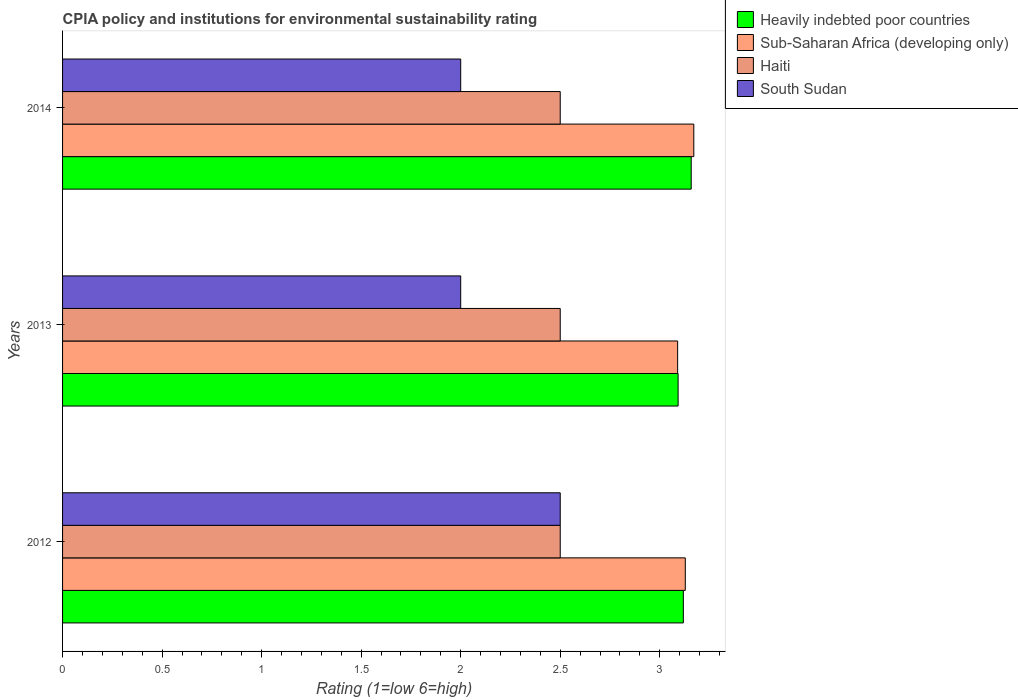How many different coloured bars are there?
Your answer should be very brief. 4. How many groups of bars are there?
Give a very brief answer. 3. Are the number of bars on each tick of the Y-axis equal?
Offer a terse response. Yes. How many bars are there on the 3rd tick from the top?
Keep it short and to the point. 4. How many bars are there on the 3rd tick from the bottom?
Provide a succinct answer. 4. In how many cases, is the number of bars for a given year not equal to the number of legend labels?
Ensure brevity in your answer.  0. Across all years, what is the maximum CPIA rating in Sub-Saharan Africa (developing only)?
Provide a succinct answer. 3.17. Across all years, what is the minimum CPIA rating in Sub-Saharan Africa (developing only)?
Ensure brevity in your answer.  3.09. What is the total CPIA rating in Heavily indebted poor countries in the graph?
Your response must be concise. 9.37. What is the difference between the CPIA rating in Sub-Saharan Africa (developing only) in 2013 and that in 2014?
Your response must be concise. -0.08. What is the difference between the CPIA rating in Heavily indebted poor countries in 2014 and the CPIA rating in Haiti in 2013?
Offer a very short reply. 0.66. What is the average CPIA rating in Heavily indebted poor countries per year?
Ensure brevity in your answer.  3.12. In how many years, is the CPIA rating in Heavily indebted poor countries greater than 0.5 ?
Provide a short and direct response. 3. What is the ratio of the CPIA rating in Heavily indebted poor countries in 2012 to that in 2013?
Offer a terse response. 1.01. Is the CPIA rating in Heavily indebted poor countries in 2012 less than that in 2014?
Provide a short and direct response. Yes. What is the difference between the highest and the second highest CPIA rating in Heavily indebted poor countries?
Your answer should be compact. 0.04. What is the difference between the highest and the lowest CPIA rating in Sub-Saharan Africa (developing only)?
Give a very brief answer. 0.08. Is the sum of the CPIA rating in Heavily indebted poor countries in 2013 and 2014 greater than the maximum CPIA rating in Haiti across all years?
Your answer should be compact. Yes. What does the 2nd bar from the top in 2014 represents?
Offer a terse response. Haiti. What does the 1st bar from the bottom in 2013 represents?
Your answer should be very brief. Heavily indebted poor countries. Is it the case that in every year, the sum of the CPIA rating in Haiti and CPIA rating in Heavily indebted poor countries is greater than the CPIA rating in Sub-Saharan Africa (developing only)?
Your answer should be compact. Yes. Are all the bars in the graph horizontal?
Provide a short and direct response. Yes. How many years are there in the graph?
Your response must be concise. 3. Are the values on the major ticks of X-axis written in scientific E-notation?
Provide a short and direct response. No. Does the graph contain any zero values?
Offer a terse response. No. How many legend labels are there?
Give a very brief answer. 4. How are the legend labels stacked?
Offer a very short reply. Vertical. What is the title of the graph?
Offer a terse response. CPIA policy and institutions for environmental sustainability rating. What is the Rating (1=low 6=high) of Heavily indebted poor countries in 2012?
Your answer should be compact. 3.12. What is the Rating (1=low 6=high) in Sub-Saharan Africa (developing only) in 2012?
Your response must be concise. 3.13. What is the Rating (1=low 6=high) in South Sudan in 2012?
Offer a very short reply. 2.5. What is the Rating (1=low 6=high) of Heavily indebted poor countries in 2013?
Give a very brief answer. 3.09. What is the Rating (1=low 6=high) of Sub-Saharan Africa (developing only) in 2013?
Ensure brevity in your answer.  3.09. What is the Rating (1=low 6=high) of South Sudan in 2013?
Your answer should be very brief. 2. What is the Rating (1=low 6=high) of Heavily indebted poor countries in 2014?
Your response must be concise. 3.16. What is the Rating (1=low 6=high) of Sub-Saharan Africa (developing only) in 2014?
Provide a short and direct response. 3.17. What is the Rating (1=low 6=high) of Haiti in 2014?
Provide a short and direct response. 2.5. What is the Rating (1=low 6=high) in South Sudan in 2014?
Your answer should be compact. 2. Across all years, what is the maximum Rating (1=low 6=high) in Heavily indebted poor countries?
Offer a very short reply. 3.16. Across all years, what is the maximum Rating (1=low 6=high) of Sub-Saharan Africa (developing only)?
Your answer should be compact. 3.17. Across all years, what is the maximum Rating (1=low 6=high) of Haiti?
Keep it short and to the point. 2.5. Across all years, what is the minimum Rating (1=low 6=high) in Heavily indebted poor countries?
Your answer should be very brief. 3.09. Across all years, what is the minimum Rating (1=low 6=high) in Sub-Saharan Africa (developing only)?
Offer a terse response. 3.09. Across all years, what is the minimum Rating (1=low 6=high) in Haiti?
Provide a short and direct response. 2.5. What is the total Rating (1=low 6=high) of Heavily indebted poor countries in the graph?
Offer a very short reply. 9.37. What is the total Rating (1=low 6=high) of Sub-Saharan Africa (developing only) in the graph?
Keep it short and to the point. 9.39. What is the total Rating (1=low 6=high) in Haiti in the graph?
Provide a short and direct response. 7.5. What is the total Rating (1=low 6=high) of South Sudan in the graph?
Ensure brevity in your answer.  6.5. What is the difference between the Rating (1=low 6=high) of Heavily indebted poor countries in 2012 and that in 2013?
Keep it short and to the point. 0.03. What is the difference between the Rating (1=low 6=high) of Sub-Saharan Africa (developing only) in 2012 and that in 2013?
Make the answer very short. 0.04. What is the difference between the Rating (1=low 6=high) of Haiti in 2012 and that in 2013?
Offer a terse response. 0. What is the difference between the Rating (1=low 6=high) in Heavily indebted poor countries in 2012 and that in 2014?
Provide a succinct answer. -0.04. What is the difference between the Rating (1=low 6=high) in Sub-Saharan Africa (developing only) in 2012 and that in 2014?
Your response must be concise. -0.04. What is the difference between the Rating (1=low 6=high) in South Sudan in 2012 and that in 2014?
Offer a terse response. 0.5. What is the difference between the Rating (1=low 6=high) of Heavily indebted poor countries in 2013 and that in 2014?
Ensure brevity in your answer.  -0.07. What is the difference between the Rating (1=low 6=high) of Sub-Saharan Africa (developing only) in 2013 and that in 2014?
Provide a succinct answer. -0.08. What is the difference between the Rating (1=low 6=high) of Haiti in 2013 and that in 2014?
Give a very brief answer. 0. What is the difference between the Rating (1=low 6=high) in South Sudan in 2013 and that in 2014?
Offer a terse response. 0. What is the difference between the Rating (1=low 6=high) of Heavily indebted poor countries in 2012 and the Rating (1=low 6=high) of Sub-Saharan Africa (developing only) in 2013?
Your answer should be very brief. 0.03. What is the difference between the Rating (1=low 6=high) of Heavily indebted poor countries in 2012 and the Rating (1=low 6=high) of Haiti in 2013?
Ensure brevity in your answer.  0.62. What is the difference between the Rating (1=low 6=high) in Heavily indebted poor countries in 2012 and the Rating (1=low 6=high) in South Sudan in 2013?
Give a very brief answer. 1.12. What is the difference between the Rating (1=low 6=high) in Sub-Saharan Africa (developing only) in 2012 and the Rating (1=low 6=high) in Haiti in 2013?
Your answer should be very brief. 0.63. What is the difference between the Rating (1=low 6=high) of Sub-Saharan Africa (developing only) in 2012 and the Rating (1=low 6=high) of South Sudan in 2013?
Provide a short and direct response. 1.13. What is the difference between the Rating (1=low 6=high) of Heavily indebted poor countries in 2012 and the Rating (1=low 6=high) of Sub-Saharan Africa (developing only) in 2014?
Keep it short and to the point. -0.05. What is the difference between the Rating (1=low 6=high) of Heavily indebted poor countries in 2012 and the Rating (1=low 6=high) of Haiti in 2014?
Your response must be concise. 0.62. What is the difference between the Rating (1=low 6=high) in Heavily indebted poor countries in 2012 and the Rating (1=low 6=high) in South Sudan in 2014?
Make the answer very short. 1.12. What is the difference between the Rating (1=low 6=high) in Sub-Saharan Africa (developing only) in 2012 and the Rating (1=low 6=high) in Haiti in 2014?
Offer a terse response. 0.63. What is the difference between the Rating (1=low 6=high) in Sub-Saharan Africa (developing only) in 2012 and the Rating (1=low 6=high) in South Sudan in 2014?
Provide a succinct answer. 1.13. What is the difference between the Rating (1=low 6=high) in Heavily indebted poor countries in 2013 and the Rating (1=low 6=high) in Sub-Saharan Africa (developing only) in 2014?
Offer a very short reply. -0.08. What is the difference between the Rating (1=low 6=high) in Heavily indebted poor countries in 2013 and the Rating (1=low 6=high) in Haiti in 2014?
Make the answer very short. 0.59. What is the difference between the Rating (1=low 6=high) of Heavily indebted poor countries in 2013 and the Rating (1=low 6=high) of South Sudan in 2014?
Your answer should be compact. 1.09. What is the difference between the Rating (1=low 6=high) in Sub-Saharan Africa (developing only) in 2013 and the Rating (1=low 6=high) in Haiti in 2014?
Offer a very short reply. 0.59. What is the difference between the Rating (1=low 6=high) of Sub-Saharan Africa (developing only) in 2013 and the Rating (1=low 6=high) of South Sudan in 2014?
Give a very brief answer. 1.09. What is the difference between the Rating (1=low 6=high) of Haiti in 2013 and the Rating (1=low 6=high) of South Sudan in 2014?
Keep it short and to the point. 0.5. What is the average Rating (1=low 6=high) in Heavily indebted poor countries per year?
Keep it short and to the point. 3.12. What is the average Rating (1=low 6=high) in Sub-Saharan Africa (developing only) per year?
Offer a terse response. 3.13. What is the average Rating (1=low 6=high) in South Sudan per year?
Provide a succinct answer. 2.17. In the year 2012, what is the difference between the Rating (1=low 6=high) of Heavily indebted poor countries and Rating (1=low 6=high) of Sub-Saharan Africa (developing only)?
Your answer should be very brief. -0.01. In the year 2012, what is the difference between the Rating (1=low 6=high) of Heavily indebted poor countries and Rating (1=low 6=high) of Haiti?
Your response must be concise. 0.62. In the year 2012, what is the difference between the Rating (1=low 6=high) in Heavily indebted poor countries and Rating (1=low 6=high) in South Sudan?
Give a very brief answer. 0.62. In the year 2012, what is the difference between the Rating (1=low 6=high) in Sub-Saharan Africa (developing only) and Rating (1=low 6=high) in Haiti?
Your response must be concise. 0.63. In the year 2012, what is the difference between the Rating (1=low 6=high) in Sub-Saharan Africa (developing only) and Rating (1=low 6=high) in South Sudan?
Provide a short and direct response. 0.63. In the year 2012, what is the difference between the Rating (1=low 6=high) of Haiti and Rating (1=low 6=high) of South Sudan?
Your answer should be compact. 0. In the year 2013, what is the difference between the Rating (1=low 6=high) of Heavily indebted poor countries and Rating (1=low 6=high) of Sub-Saharan Africa (developing only)?
Keep it short and to the point. 0. In the year 2013, what is the difference between the Rating (1=low 6=high) of Heavily indebted poor countries and Rating (1=low 6=high) of Haiti?
Offer a very short reply. 0.59. In the year 2013, what is the difference between the Rating (1=low 6=high) of Heavily indebted poor countries and Rating (1=low 6=high) of South Sudan?
Give a very brief answer. 1.09. In the year 2013, what is the difference between the Rating (1=low 6=high) in Sub-Saharan Africa (developing only) and Rating (1=low 6=high) in Haiti?
Ensure brevity in your answer.  0.59. In the year 2013, what is the difference between the Rating (1=low 6=high) in Sub-Saharan Africa (developing only) and Rating (1=low 6=high) in South Sudan?
Your answer should be compact. 1.09. In the year 2013, what is the difference between the Rating (1=low 6=high) in Haiti and Rating (1=low 6=high) in South Sudan?
Keep it short and to the point. 0.5. In the year 2014, what is the difference between the Rating (1=low 6=high) in Heavily indebted poor countries and Rating (1=low 6=high) in Sub-Saharan Africa (developing only)?
Keep it short and to the point. -0.01. In the year 2014, what is the difference between the Rating (1=low 6=high) of Heavily indebted poor countries and Rating (1=low 6=high) of Haiti?
Your answer should be very brief. 0.66. In the year 2014, what is the difference between the Rating (1=low 6=high) in Heavily indebted poor countries and Rating (1=low 6=high) in South Sudan?
Your answer should be compact. 1.16. In the year 2014, what is the difference between the Rating (1=low 6=high) of Sub-Saharan Africa (developing only) and Rating (1=low 6=high) of Haiti?
Offer a terse response. 0.67. In the year 2014, what is the difference between the Rating (1=low 6=high) in Sub-Saharan Africa (developing only) and Rating (1=low 6=high) in South Sudan?
Your answer should be very brief. 1.17. In the year 2014, what is the difference between the Rating (1=low 6=high) of Haiti and Rating (1=low 6=high) of South Sudan?
Keep it short and to the point. 0.5. What is the ratio of the Rating (1=low 6=high) of Heavily indebted poor countries in 2012 to that in 2013?
Provide a short and direct response. 1.01. What is the ratio of the Rating (1=low 6=high) of Sub-Saharan Africa (developing only) in 2012 to that in 2013?
Make the answer very short. 1.01. What is the ratio of the Rating (1=low 6=high) of South Sudan in 2012 to that in 2013?
Make the answer very short. 1.25. What is the ratio of the Rating (1=low 6=high) in Heavily indebted poor countries in 2012 to that in 2014?
Make the answer very short. 0.99. What is the ratio of the Rating (1=low 6=high) of Sub-Saharan Africa (developing only) in 2012 to that in 2014?
Provide a succinct answer. 0.99. What is the ratio of the Rating (1=low 6=high) in Haiti in 2012 to that in 2014?
Ensure brevity in your answer.  1. What is the ratio of the Rating (1=low 6=high) in Heavily indebted poor countries in 2013 to that in 2014?
Ensure brevity in your answer.  0.98. What is the ratio of the Rating (1=low 6=high) in Sub-Saharan Africa (developing only) in 2013 to that in 2014?
Give a very brief answer. 0.97. What is the ratio of the Rating (1=low 6=high) of South Sudan in 2013 to that in 2014?
Your response must be concise. 1. What is the difference between the highest and the second highest Rating (1=low 6=high) of Heavily indebted poor countries?
Give a very brief answer. 0.04. What is the difference between the highest and the second highest Rating (1=low 6=high) in Sub-Saharan Africa (developing only)?
Offer a very short reply. 0.04. What is the difference between the highest and the second highest Rating (1=low 6=high) of Haiti?
Ensure brevity in your answer.  0. What is the difference between the highest and the second highest Rating (1=low 6=high) of South Sudan?
Offer a very short reply. 0.5. What is the difference between the highest and the lowest Rating (1=low 6=high) of Heavily indebted poor countries?
Your answer should be compact. 0.07. What is the difference between the highest and the lowest Rating (1=low 6=high) of Sub-Saharan Africa (developing only)?
Provide a succinct answer. 0.08. 